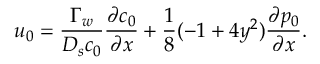<formula> <loc_0><loc_0><loc_500><loc_500>u _ { 0 } = \frac { \Gamma _ { w } } { D _ { s } c _ { 0 } } \frac { \partial c _ { 0 } } { \partial x } + \frac { 1 } { 8 } ( - 1 + 4 y ^ { 2 } ) \frac { \partial p _ { 0 } } { \partial x } .</formula> 